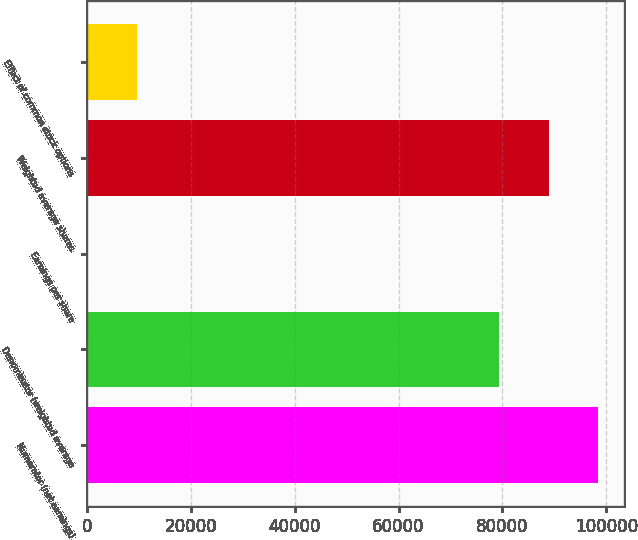Convert chart to OTSL. <chart><loc_0><loc_0><loc_500><loc_500><bar_chart><fcel>Numerator (net earnings)<fcel>Denominator (weighted average<fcel>Earnings per share<fcel>Weighted average shares<fcel>Effect of common stock options<nl><fcel>98491.6<fcel>79400<fcel>1.2<fcel>88945.8<fcel>9546.98<nl></chart> 